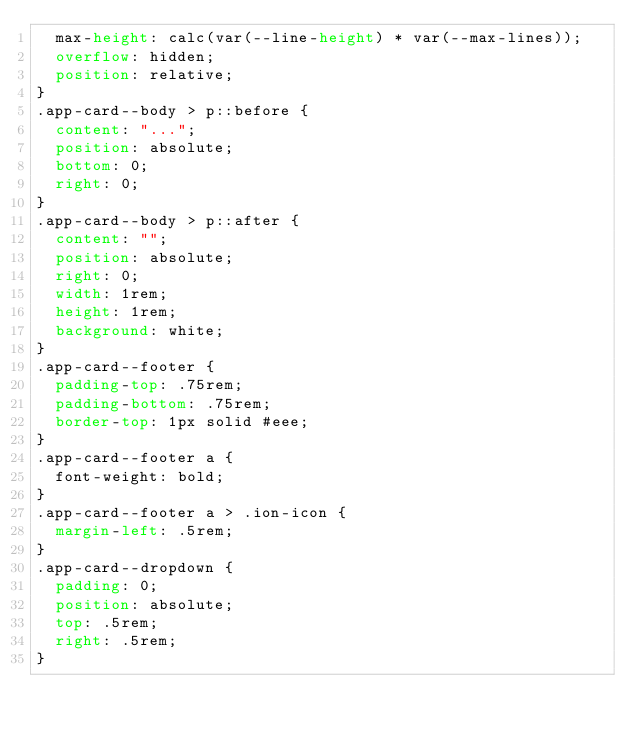Convert code to text. <code><loc_0><loc_0><loc_500><loc_500><_CSS_>  max-height: calc(var(--line-height) * var(--max-lines));
  overflow: hidden;
  position: relative;
}
.app-card--body > p::before {
  content: "...";
  position: absolute;
  bottom: 0;
  right: 0;
}
.app-card--body > p::after {
  content: "";
  position: absolute;
  right: 0;
  width: 1rem;
  height: 1rem;
  background: white;
}
.app-card--footer {
  padding-top: .75rem;
  padding-bottom: .75rem;
  border-top: 1px solid #eee;
}
.app-card--footer a {
  font-weight: bold;
}
.app-card--footer a > .ion-icon {
  margin-left: .5rem;
}
.app-card--dropdown {
  padding: 0;
  position: absolute;
  top: .5rem;
  right: .5rem;
}
</code> 